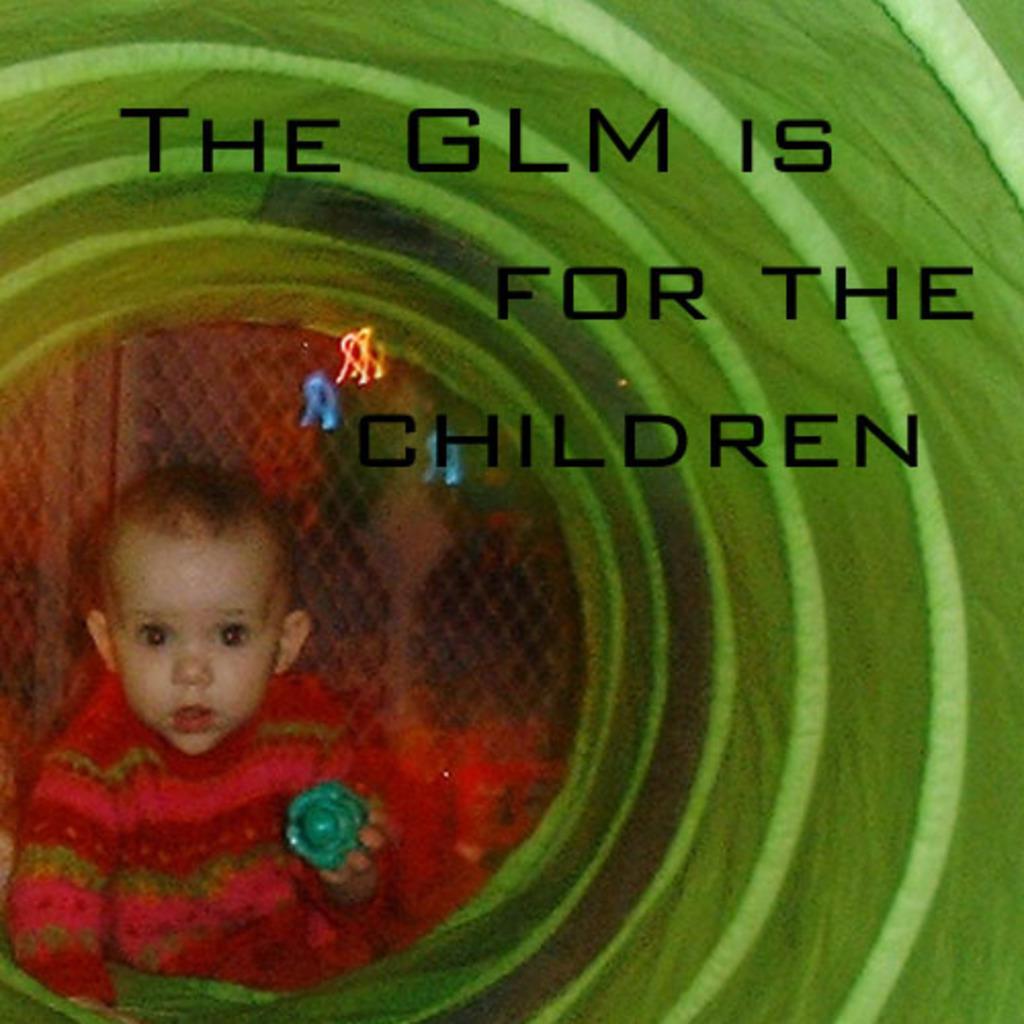How would you summarize this image in a sentence or two? In this picture we can see a baby sitting in a plastic container, baby is holding an object and we can see some text. 